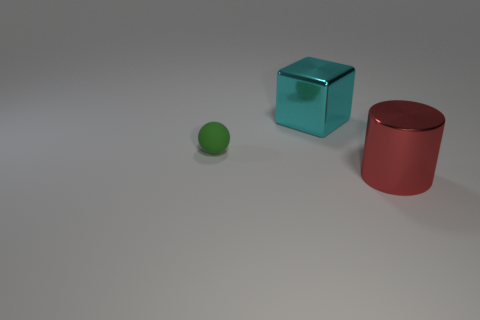The thing on the left side of the shiny object that is to the left of the cylinder is made of what material?
Provide a short and direct response. Rubber. Do the large shiny object behind the matte object and the green object that is left of the large cylinder have the same shape?
Offer a terse response. No. How big is the object that is in front of the cyan object and behind the big red object?
Offer a terse response. Small. Does the large thing that is behind the big red metal object have the same material as the green object?
Provide a succinct answer. No. Is there any other thing that is the same size as the sphere?
Give a very brief answer. No. Is the number of metallic things on the left side of the large metallic cylinder less than the number of objects right of the small rubber thing?
Your answer should be very brief. Yes. What number of large shiny blocks are left of the object on the right side of the large shiny thing that is behind the large red thing?
Ensure brevity in your answer.  1. What number of large cyan metallic things are in front of the red metallic object?
Make the answer very short. 0. What number of big cubes have the same material as the cylinder?
Offer a terse response. 1. There is a cylinder that is the same material as the block; what color is it?
Your response must be concise. Red. 